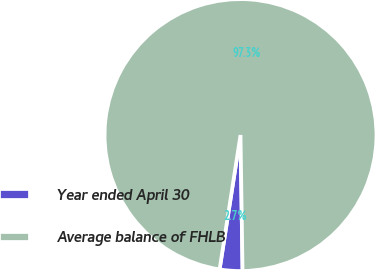<chart> <loc_0><loc_0><loc_500><loc_500><pie_chart><fcel>Year ended April 30<fcel>Average balance of FHLB<nl><fcel>2.7%<fcel>97.3%<nl></chart> 